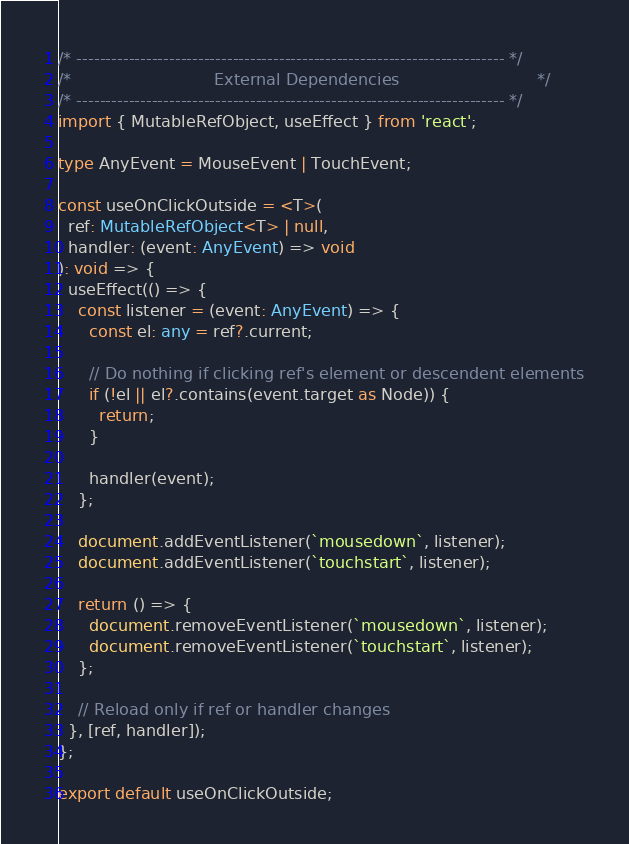Convert code to text. <code><loc_0><loc_0><loc_500><loc_500><_TypeScript_>/* -------------------------------------------------------------------------- */
/*                            External Dependencies                           */
/* -------------------------------------------------------------------------- */
import { MutableRefObject, useEffect } from 'react';

type AnyEvent = MouseEvent | TouchEvent;

const useOnClickOutside = <T>(
  ref: MutableRefObject<T> | null,
  handler: (event: AnyEvent) => void
): void => {
  useEffect(() => {
    const listener = (event: AnyEvent) => {
      const el: any = ref?.current;

      // Do nothing if clicking ref's element or descendent elements
      if (!el || el?.contains(event.target as Node)) {
        return;
      }

      handler(event);
    };

    document.addEventListener(`mousedown`, listener);
    document.addEventListener(`touchstart`, listener);

    return () => {
      document.removeEventListener(`mousedown`, listener);
      document.removeEventListener(`touchstart`, listener);
    };

    // Reload only if ref or handler changes
  }, [ref, handler]);
};

export default useOnClickOutside;
</code> 